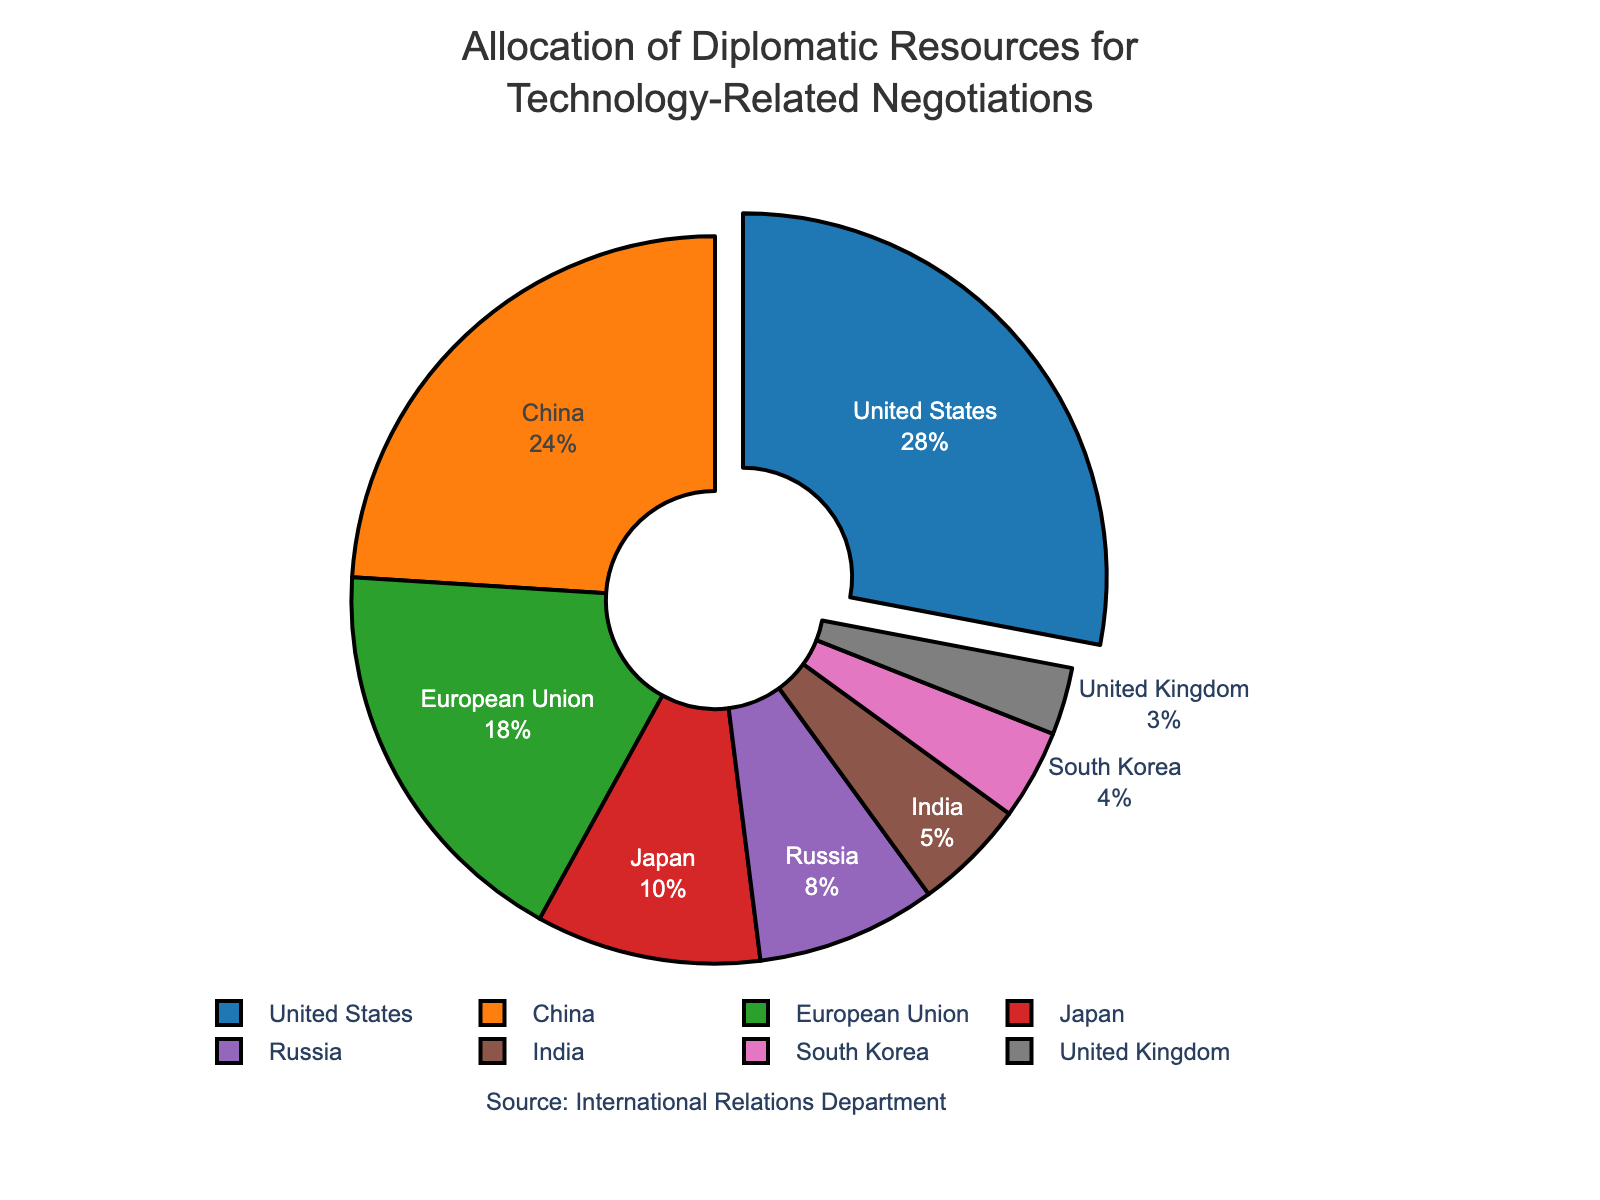Which two countries together allocate more than half of the total diplomatic resources for technology-related negotiations? To find the answer, sum the percentages allocated by the United States and China: 28% + 24% = 52%. This is more than half of the total.
Answer: The United States and China Which country allocates the least resources for technology-related negotiations and what is their percentage allocation? The figure shows that the United Kingdom allocates the smallest percentage of resources, which is 3%.
Answer: The United Kingdom with 3% How much more resources does the United States allocate compared to South Korea? Subtract South Korea's percentage from the United States' percentage: 28% - 4% = 24%. The United States allocates 24% more resources than South Korea.
Answer: 24% What proportion of resources is allocated by Japan and the European Union combined? Sum the percentages of Japan and the European Union: 10% + 18% = 28%.
Answer: 28% If Russia and India were to combine their resources, where would they rank in comparison to the European Union? Adding Russia and India's resources gives 8% + 5% = 13%. The European Union allocates 18%, which is higher than Russia and India's combined 13%.
Answer: Below the European Union Between Japan and India, which country allocates a larger share of resources and by how much? Japan allocates 10% while India allocates 5%. The difference is 10% - 5% = 5%.
Answer: Japan by 5% Which country is represented by the most prominent section of the pie chart and why? The United States is represented by the most prominent section because it has the highest percentage allocation at 28%.
Answer: The United States How does the percentage allocation of the European Union compare to that of South Korea and the United Kingdom combined? The European Union allocates 18%, while South Korea and the United Kingdom together allocate 4% + 3% = 7%. The European Union allocates more than the combined total of South Korea and the United Kingdom.
Answer: The European Union allocates more What is the median percentage allocation of all the countries listed? The percentages in ascending order are: 3%, 4%, 5%, 8%, 10%, 18%, 24%, 28%. As there are 8 countries, the median is the average of the 4th and 5th values: (8% + 10%) / 2 = 9%.
Answer: 9% Is China's allocation larger than the combined allocations of Japan and India? China allocates 24%, while Japan and India together allocate 10% + 5% = 15%. China's allocation is therefore larger.
Answer: Yes 